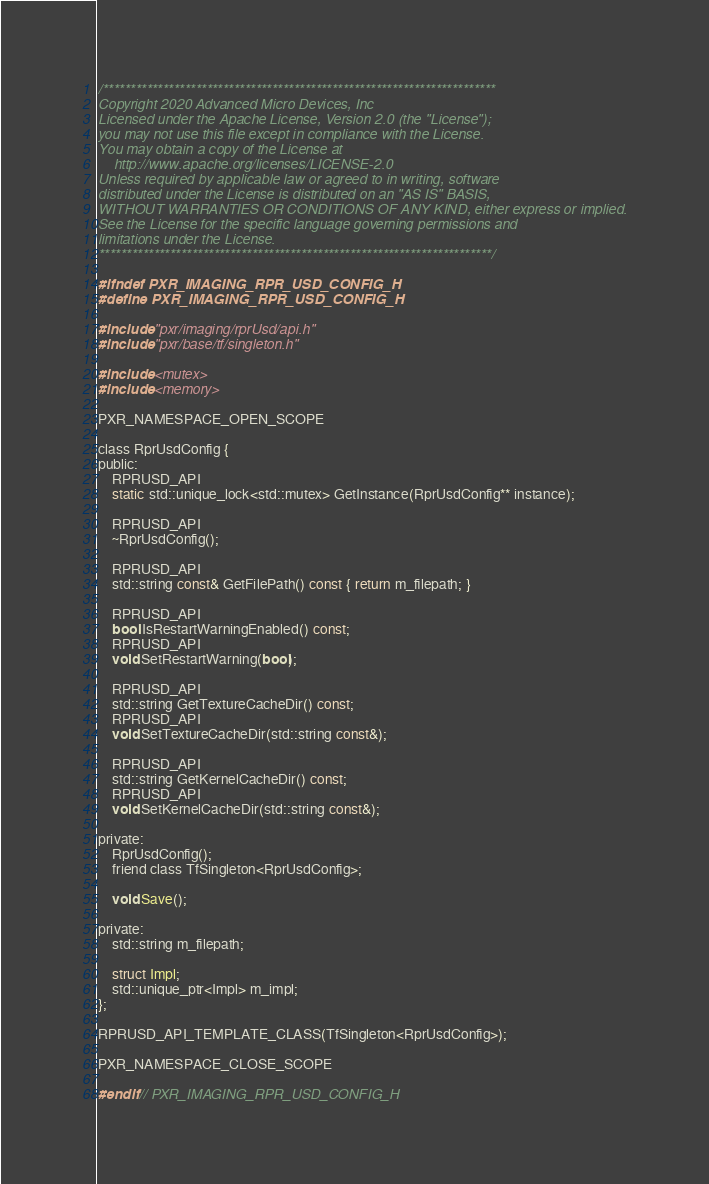<code> <loc_0><loc_0><loc_500><loc_500><_C_>/************************************************************************
Copyright 2020 Advanced Micro Devices, Inc
Licensed under the Apache License, Version 2.0 (the "License");
you may not use this file except in compliance with the License.
You may obtain a copy of the License at
    http://www.apache.org/licenses/LICENSE-2.0
Unless required by applicable law or agreed to in writing, software
distributed under the License is distributed on an "AS IS" BASIS,
WITHOUT WARRANTIES OR CONDITIONS OF ANY KIND, either express or implied.
See the License for the specific language governing permissions and
limitations under the License.
************************************************************************/

#ifndef PXR_IMAGING_RPR_USD_CONFIG_H
#define PXR_IMAGING_RPR_USD_CONFIG_H

#include "pxr/imaging/rprUsd/api.h"
#include "pxr/base/tf/singleton.h"

#include <mutex>
#include <memory>

PXR_NAMESPACE_OPEN_SCOPE

class RprUsdConfig {
public:
    RPRUSD_API
    static std::unique_lock<std::mutex> GetInstance(RprUsdConfig** instance);

    RPRUSD_API
    ~RprUsdConfig();

    RPRUSD_API
    std::string const& GetFilePath() const { return m_filepath; }

    RPRUSD_API
    bool IsRestartWarningEnabled() const;
    RPRUSD_API
    void SetRestartWarning(bool);

    RPRUSD_API
    std::string GetTextureCacheDir() const;
    RPRUSD_API
    void SetTextureCacheDir(std::string const&);

    RPRUSD_API
    std::string GetKernelCacheDir() const;
    RPRUSD_API
    void SetKernelCacheDir(std::string const&);

private:
    RprUsdConfig();
    friend class TfSingleton<RprUsdConfig>;

    void Save();

private:
    std::string m_filepath;

    struct Impl;
    std::unique_ptr<Impl> m_impl;
};

RPRUSD_API_TEMPLATE_CLASS(TfSingleton<RprUsdConfig>);

PXR_NAMESPACE_CLOSE_SCOPE

#endif // PXR_IMAGING_RPR_USD_CONFIG_H
</code> 